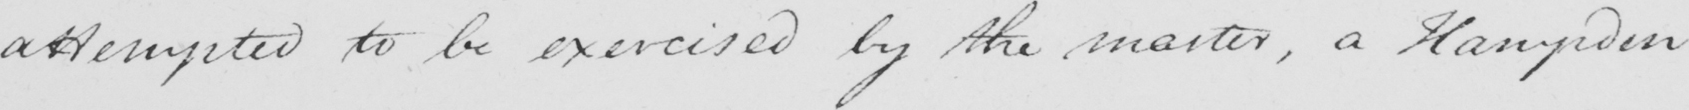Can you tell me what this handwritten text says? attempted to be exercised by the master , a Hampden 